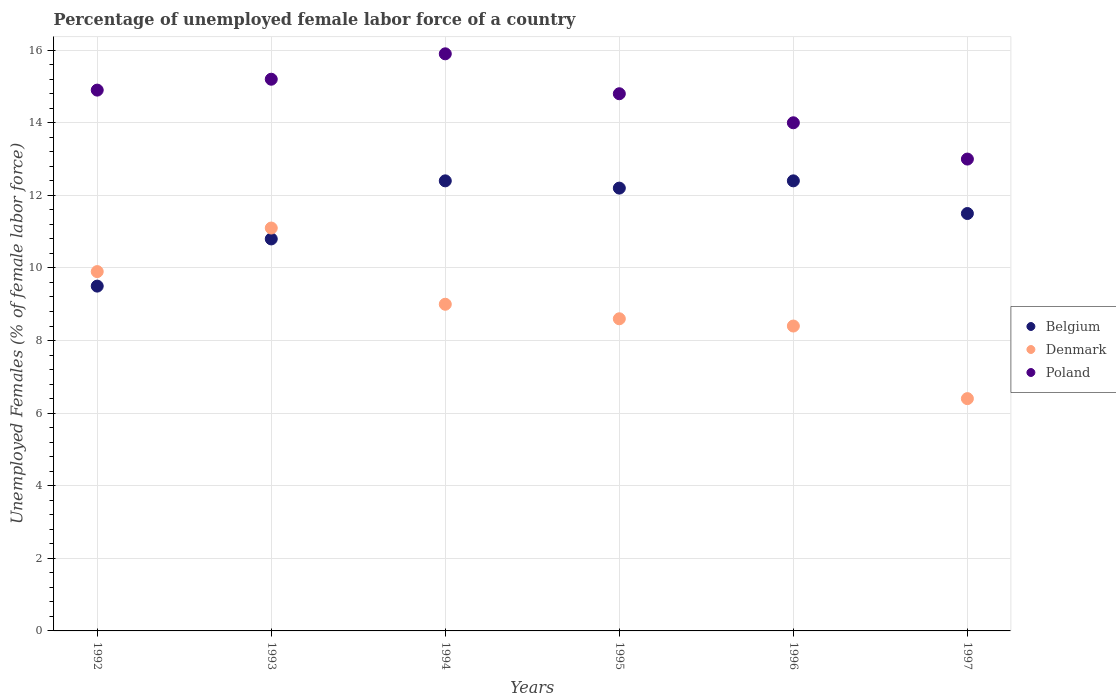How many different coloured dotlines are there?
Offer a very short reply. 3. Is the number of dotlines equal to the number of legend labels?
Give a very brief answer. Yes. What is the percentage of unemployed female labor force in Poland in 1993?
Provide a succinct answer. 15.2. Across all years, what is the maximum percentage of unemployed female labor force in Belgium?
Your answer should be very brief. 12.4. Across all years, what is the minimum percentage of unemployed female labor force in Denmark?
Provide a succinct answer. 6.4. In which year was the percentage of unemployed female labor force in Poland maximum?
Your answer should be compact. 1994. In which year was the percentage of unemployed female labor force in Poland minimum?
Your response must be concise. 1997. What is the total percentage of unemployed female labor force in Denmark in the graph?
Your answer should be compact. 53.4. What is the difference between the percentage of unemployed female labor force in Denmark in 1993 and that in 1997?
Your answer should be very brief. 4.7. What is the difference between the percentage of unemployed female labor force in Belgium in 1994 and the percentage of unemployed female labor force in Denmark in 1995?
Your response must be concise. 3.8. What is the average percentage of unemployed female labor force in Belgium per year?
Keep it short and to the point. 11.47. In the year 1993, what is the difference between the percentage of unemployed female labor force in Poland and percentage of unemployed female labor force in Denmark?
Ensure brevity in your answer.  4.1. What is the ratio of the percentage of unemployed female labor force in Poland in 1992 to that in 1995?
Provide a succinct answer. 1.01. What is the difference between the highest and the second highest percentage of unemployed female labor force in Denmark?
Make the answer very short. 1.2. What is the difference between the highest and the lowest percentage of unemployed female labor force in Poland?
Give a very brief answer. 2.9. Is the sum of the percentage of unemployed female labor force in Denmark in 1992 and 1995 greater than the maximum percentage of unemployed female labor force in Poland across all years?
Give a very brief answer. Yes. Is the percentage of unemployed female labor force in Denmark strictly less than the percentage of unemployed female labor force in Poland over the years?
Your answer should be compact. Yes. What is the difference between two consecutive major ticks on the Y-axis?
Offer a very short reply. 2. Are the values on the major ticks of Y-axis written in scientific E-notation?
Ensure brevity in your answer.  No. Does the graph contain any zero values?
Your answer should be compact. No. Where does the legend appear in the graph?
Provide a succinct answer. Center right. How are the legend labels stacked?
Offer a terse response. Vertical. What is the title of the graph?
Ensure brevity in your answer.  Percentage of unemployed female labor force of a country. What is the label or title of the Y-axis?
Ensure brevity in your answer.  Unemployed Females (% of female labor force). What is the Unemployed Females (% of female labor force) in Denmark in 1992?
Your answer should be very brief. 9.9. What is the Unemployed Females (% of female labor force) of Poland in 1992?
Provide a succinct answer. 14.9. What is the Unemployed Females (% of female labor force) of Belgium in 1993?
Offer a very short reply. 10.8. What is the Unemployed Females (% of female labor force) in Denmark in 1993?
Ensure brevity in your answer.  11.1. What is the Unemployed Females (% of female labor force) in Poland in 1993?
Your answer should be very brief. 15.2. What is the Unemployed Females (% of female labor force) in Belgium in 1994?
Ensure brevity in your answer.  12.4. What is the Unemployed Females (% of female labor force) of Denmark in 1994?
Provide a short and direct response. 9. What is the Unemployed Females (% of female labor force) of Poland in 1994?
Provide a succinct answer. 15.9. What is the Unemployed Females (% of female labor force) of Belgium in 1995?
Make the answer very short. 12.2. What is the Unemployed Females (% of female labor force) in Denmark in 1995?
Offer a very short reply. 8.6. What is the Unemployed Females (% of female labor force) in Poland in 1995?
Your answer should be very brief. 14.8. What is the Unemployed Females (% of female labor force) of Belgium in 1996?
Make the answer very short. 12.4. What is the Unemployed Females (% of female labor force) of Denmark in 1996?
Offer a very short reply. 8.4. What is the Unemployed Females (% of female labor force) of Belgium in 1997?
Ensure brevity in your answer.  11.5. What is the Unemployed Females (% of female labor force) of Denmark in 1997?
Your response must be concise. 6.4. Across all years, what is the maximum Unemployed Females (% of female labor force) of Belgium?
Your answer should be compact. 12.4. Across all years, what is the maximum Unemployed Females (% of female labor force) in Denmark?
Your answer should be compact. 11.1. Across all years, what is the maximum Unemployed Females (% of female labor force) in Poland?
Make the answer very short. 15.9. Across all years, what is the minimum Unemployed Females (% of female labor force) in Belgium?
Your answer should be compact. 9.5. Across all years, what is the minimum Unemployed Females (% of female labor force) of Denmark?
Offer a terse response. 6.4. Across all years, what is the minimum Unemployed Females (% of female labor force) in Poland?
Offer a very short reply. 13. What is the total Unemployed Females (% of female labor force) of Belgium in the graph?
Offer a very short reply. 68.8. What is the total Unemployed Females (% of female labor force) of Denmark in the graph?
Give a very brief answer. 53.4. What is the total Unemployed Females (% of female labor force) in Poland in the graph?
Provide a short and direct response. 87.8. What is the difference between the Unemployed Females (% of female labor force) of Denmark in 1992 and that in 1993?
Provide a succinct answer. -1.2. What is the difference between the Unemployed Females (% of female labor force) in Poland in 1992 and that in 1993?
Make the answer very short. -0.3. What is the difference between the Unemployed Females (% of female labor force) of Belgium in 1992 and that in 1994?
Offer a terse response. -2.9. What is the difference between the Unemployed Females (% of female labor force) in Denmark in 1992 and that in 1994?
Keep it short and to the point. 0.9. What is the difference between the Unemployed Females (% of female labor force) in Poland in 1992 and that in 1994?
Your response must be concise. -1. What is the difference between the Unemployed Females (% of female labor force) in Poland in 1992 and that in 1995?
Give a very brief answer. 0.1. What is the difference between the Unemployed Females (% of female labor force) of Belgium in 1992 and that in 1997?
Keep it short and to the point. -2. What is the difference between the Unemployed Females (% of female labor force) in Poland in 1993 and that in 1994?
Your answer should be very brief. -0.7. What is the difference between the Unemployed Females (% of female labor force) of Belgium in 1993 and that in 1995?
Give a very brief answer. -1.4. What is the difference between the Unemployed Females (% of female labor force) of Poland in 1993 and that in 1995?
Your answer should be compact. 0.4. What is the difference between the Unemployed Females (% of female labor force) in Belgium in 1993 and that in 1996?
Provide a short and direct response. -1.6. What is the difference between the Unemployed Females (% of female labor force) in Denmark in 1993 and that in 1996?
Offer a very short reply. 2.7. What is the difference between the Unemployed Females (% of female labor force) in Poland in 1993 and that in 1996?
Keep it short and to the point. 1.2. What is the difference between the Unemployed Females (% of female labor force) of Belgium in 1994 and that in 1995?
Your response must be concise. 0.2. What is the difference between the Unemployed Females (% of female labor force) in Denmark in 1994 and that in 1995?
Provide a succinct answer. 0.4. What is the difference between the Unemployed Females (% of female labor force) in Poland in 1994 and that in 1996?
Provide a short and direct response. 1.9. What is the difference between the Unemployed Females (% of female labor force) of Belgium in 1994 and that in 1997?
Ensure brevity in your answer.  0.9. What is the difference between the Unemployed Females (% of female labor force) of Denmark in 1995 and that in 1997?
Make the answer very short. 2.2. What is the difference between the Unemployed Females (% of female labor force) in Poland in 1995 and that in 1997?
Offer a terse response. 1.8. What is the difference between the Unemployed Females (% of female labor force) in Denmark in 1996 and that in 1997?
Give a very brief answer. 2. What is the difference between the Unemployed Females (% of female labor force) in Denmark in 1992 and the Unemployed Females (% of female labor force) in Poland in 1993?
Offer a terse response. -5.3. What is the difference between the Unemployed Females (% of female labor force) in Belgium in 1992 and the Unemployed Females (% of female labor force) in Poland in 1994?
Provide a succinct answer. -6.4. What is the difference between the Unemployed Females (% of female labor force) in Denmark in 1992 and the Unemployed Females (% of female labor force) in Poland in 1994?
Provide a short and direct response. -6. What is the difference between the Unemployed Females (% of female labor force) of Belgium in 1992 and the Unemployed Females (% of female labor force) of Denmark in 1995?
Offer a terse response. 0.9. What is the difference between the Unemployed Females (% of female labor force) in Belgium in 1992 and the Unemployed Females (% of female labor force) in Poland in 1995?
Keep it short and to the point. -5.3. What is the difference between the Unemployed Females (% of female labor force) in Denmark in 1992 and the Unemployed Females (% of female labor force) in Poland in 1996?
Ensure brevity in your answer.  -4.1. What is the difference between the Unemployed Females (% of female labor force) in Denmark in 1992 and the Unemployed Females (% of female labor force) in Poland in 1997?
Your answer should be compact. -3.1. What is the difference between the Unemployed Females (% of female labor force) in Denmark in 1993 and the Unemployed Females (% of female labor force) in Poland in 1994?
Provide a short and direct response. -4.8. What is the difference between the Unemployed Females (% of female labor force) in Belgium in 1993 and the Unemployed Females (% of female labor force) in Poland in 1995?
Your response must be concise. -4. What is the difference between the Unemployed Females (% of female labor force) of Belgium in 1993 and the Unemployed Females (% of female labor force) of Denmark in 1996?
Ensure brevity in your answer.  2.4. What is the difference between the Unemployed Females (% of female labor force) of Belgium in 1993 and the Unemployed Females (% of female labor force) of Poland in 1996?
Offer a terse response. -3.2. What is the difference between the Unemployed Females (% of female labor force) of Belgium in 1993 and the Unemployed Females (% of female labor force) of Denmark in 1997?
Your answer should be very brief. 4.4. What is the difference between the Unemployed Females (% of female labor force) of Denmark in 1993 and the Unemployed Females (% of female labor force) of Poland in 1997?
Make the answer very short. -1.9. What is the difference between the Unemployed Females (% of female labor force) of Belgium in 1994 and the Unemployed Females (% of female labor force) of Poland in 1995?
Offer a terse response. -2.4. What is the difference between the Unemployed Females (% of female labor force) in Denmark in 1994 and the Unemployed Females (% of female labor force) in Poland in 1995?
Provide a short and direct response. -5.8. What is the difference between the Unemployed Females (% of female labor force) of Belgium in 1994 and the Unemployed Females (% of female labor force) of Denmark in 1996?
Your answer should be very brief. 4. What is the difference between the Unemployed Females (% of female labor force) of Belgium in 1994 and the Unemployed Females (% of female labor force) of Poland in 1996?
Provide a short and direct response. -1.6. What is the difference between the Unemployed Females (% of female labor force) of Belgium in 1995 and the Unemployed Females (% of female labor force) of Poland in 1996?
Offer a terse response. -1.8. What is the difference between the Unemployed Females (% of female labor force) of Denmark in 1995 and the Unemployed Females (% of female labor force) of Poland in 1996?
Your answer should be very brief. -5.4. What is the difference between the Unemployed Females (% of female labor force) of Denmark in 1995 and the Unemployed Females (% of female labor force) of Poland in 1997?
Offer a terse response. -4.4. What is the difference between the Unemployed Females (% of female labor force) in Belgium in 1996 and the Unemployed Females (% of female labor force) in Poland in 1997?
Your answer should be compact. -0.6. What is the difference between the Unemployed Females (% of female labor force) of Denmark in 1996 and the Unemployed Females (% of female labor force) of Poland in 1997?
Offer a terse response. -4.6. What is the average Unemployed Females (% of female labor force) of Belgium per year?
Ensure brevity in your answer.  11.47. What is the average Unemployed Females (% of female labor force) in Poland per year?
Ensure brevity in your answer.  14.63. In the year 1992, what is the difference between the Unemployed Females (% of female labor force) of Belgium and Unemployed Females (% of female labor force) of Poland?
Offer a terse response. -5.4. In the year 1993, what is the difference between the Unemployed Females (% of female labor force) in Belgium and Unemployed Females (% of female labor force) in Denmark?
Provide a short and direct response. -0.3. In the year 1993, what is the difference between the Unemployed Females (% of female labor force) in Belgium and Unemployed Females (% of female labor force) in Poland?
Provide a short and direct response. -4.4. In the year 1993, what is the difference between the Unemployed Females (% of female labor force) in Denmark and Unemployed Females (% of female labor force) in Poland?
Your answer should be very brief. -4.1. In the year 1994, what is the difference between the Unemployed Females (% of female labor force) in Denmark and Unemployed Females (% of female labor force) in Poland?
Your response must be concise. -6.9. In the year 1995, what is the difference between the Unemployed Females (% of female labor force) in Belgium and Unemployed Females (% of female labor force) in Denmark?
Your answer should be very brief. 3.6. In the year 1995, what is the difference between the Unemployed Females (% of female labor force) of Belgium and Unemployed Females (% of female labor force) of Poland?
Provide a short and direct response. -2.6. In the year 1997, what is the difference between the Unemployed Females (% of female labor force) of Belgium and Unemployed Females (% of female labor force) of Denmark?
Ensure brevity in your answer.  5.1. What is the ratio of the Unemployed Females (% of female labor force) of Belgium in 1992 to that in 1993?
Provide a short and direct response. 0.88. What is the ratio of the Unemployed Females (% of female labor force) in Denmark in 1992 to that in 1993?
Your answer should be very brief. 0.89. What is the ratio of the Unemployed Females (% of female labor force) of Poland in 1992 to that in 1993?
Your response must be concise. 0.98. What is the ratio of the Unemployed Females (% of female labor force) of Belgium in 1992 to that in 1994?
Provide a succinct answer. 0.77. What is the ratio of the Unemployed Females (% of female labor force) in Denmark in 1992 to that in 1994?
Your answer should be compact. 1.1. What is the ratio of the Unemployed Females (% of female labor force) of Poland in 1992 to that in 1994?
Provide a short and direct response. 0.94. What is the ratio of the Unemployed Females (% of female labor force) in Belgium in 1992 to that in 1995?
Provide a short and direct response. 0.78. What is the ratio of the Unemployed Females (% of female labor force) in Denmark in 1992 to that in 1995?
Offer a very short reply. 1.15. What is the ratio of the Unemployed Females (% of female labor force) of Poland in 1992 to that in 1995?
Offer a terse response. 1.01. What is the ratio of the Unemployed Females (% of female labor force) in Belgium in 1992 to that in 1996?
Provide a short and direct response. 0.77. What is the ratio of the Unemployed Females (% of female labor force) in Denmark in 1992 to that in 1996?
Ensure brevity in your answer.  1.18. What is the ratio of the Unemployed Females (% of female labor force) in Poland in 1992 to that in 1996?
Ensure brevity in your answer.  1.06. What is the ratio of the Unemployed Females (% of female labor force) of Belgium in 1992 to that in 1997?
Offer a terse response. 0.83. What is the ratio of the Unemployed Females (% of female labor force) in Denmark in 1992 to that in 1997?
Provide a succinct answer. 1.55. What is the ratio of the Unemployed Females (% of female labor force) of Poland in 1992 to that in 1997?
Your answer should be very brief. 1.15. What is the ratio of the Unemployed Females (% of female labor force) in Belgium in 1993 to that in 1994?
Your answer should be compact. 0.87. What is the ratio of the Unemployed Females (% of female labor force) of Denmark in 1993 to that in 1994?
Your answer should be very brief. 1.23. What is the ratio of the Unemployed Females (% of female labor force) in Poland in 1993 to that in 1994?
Your response must be concise. 0.96. What is the ratio of the Unemployed Females (% of female labor force) in Belgium in 1993 to that in 1995?
Your answer should be very brief. 0.89. What is the ratio of the Unemployed Females (% of female labor force) of Denmark in 1993 to that in 1995?
Make the answer very short. 1.29. What is the ratio of the Unemployed Females (% of female labor force) of Poland in 1993 to that in 1995?
Make the answer very short. 1.03. What is the ratio of the Unemployed Females (% of female labor force) of Belgium in 1993 to that in 1996?
Make the answer very short. 0.87. What is the ratio of the Unemployed Females (% of female labor force) in Denmark in 1993 to that in 1996?
Your response must be concise. 1.32. What is the ratio of the Unemployed Females (% of female labor force) in Poland in 1993 to that in 1996?
Keep it short and to the point. 1.09. What is the ratio of the Unemployed Females (% of female labor force) in Belgium in 1993 to that in 1997?
Your answer should be very brief. 0.94. What is the ratio of the Unemployed Females (% of female labor force) in Denmark in 1993 to that in 1997?
Keep it short and to the point. 1.73. What is the ratio of the Unemployed Females (% of female labor force) of Poland in 1993 to that in 1997?
Your answer should be compact. 1.17. What is the ratio of the Unemployed Females (% of female labor force) of Belgium in 1994 to that in 1995?
Make the answer very short. 1.02. What is the ratio of the Unemployed Females (% of female labor force) of Denmark in 1994 to that in 1995?
Your answer should be very brief. 1.05. What is the ratio of the Unemployed Females (% of female labor force) of Poland in 1994 to that in 1995?
Provide a succinct answer. 1.07. What is the ratio of the Unemployed Females (% of female labor force) of Denmark in 1994 to that in 1996?
Offer a very short reply. 1.07. What is the ratio of the Unemployed Females (% of female labor force) of Poland in 1994 to that in 1996?
Ensure brevity in your answer.  1.14. What is the ratio of the Unemployed Females (% of female labor force) in Belgium in 1994 to that in 1997?
Provide a succinct answer. 1.08. What is the ratio of the Unemployed Females (% of female labor force) in Denmark in 1994 to that in 1997?
Provide a short and direct response. 1.41. What is the ratio of the Unemployed Females (% of female labor force) in Poland in 1994 to that in 1997?
Your response must be concise. 1.22. What is the ratio of the Unemployed Females (% of female labor force) in Belgium in 1995 to that in 1996?
Your answer should be very brief. 0.98. What is the ratio of the Unemployed Females (% of female labor force) in Denmark in 1995 to that in 1996?
Provide a succinct answer. 1.02. What is the ratio of the Unemployed Females (% of female labor force) of Poland in 1995 to that in 1996?
Give a very brief answer. 1.06. What is the ratio of the Unemployed Females (% of female labor force) of Belgium in 1995 to that in 1997?
Your answer should be very brief. 1.06. What is the ratio of the Unemployed Females (% of female labor force) in Denmark in 1995 to that in 1997?
Your answer should be very brief. 1.34. What is the ratio of the Unemployed Females (% of female labor force) of Poland in 1995 to that in 1997?
Give a very brief answer. 1.14. What is the ratio of the Unemployed Females (% of female labor force) in Belgium in 1996 to that in 1997?
Ensure brevity in your answer.  1.08. What is the ratio of the Unemployed Females (% of female labor force) in Denmark in 1996 to that in 1997?
Provide a succinct answer. 1.31. What is the difference between the highest and the second highest Unemployed Females (% of female labor force) in Denmark?
Offer a terse response. 1.2. What is the difference between the highest and the second highest Unemployed Females (% of female labor force) in Poland?
Make the answer very short. 0.7. What is the difference between the highest and the lowest Unemployed Females (% of female labor force) of Denmark?
Offer a terse response. 4.7. What is the difference between the highest and the lowest Unemployed Females (% of female labor force) in Poland?
Give a very brief answer. 2.9. 